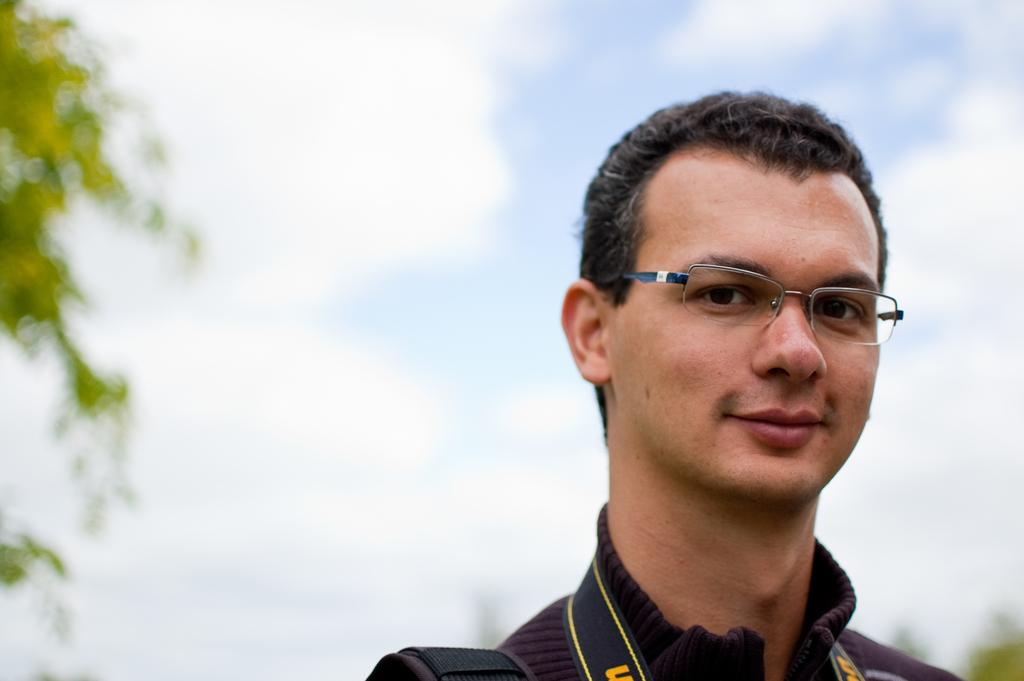What is the main subject in the foreground of the picture? There is a person in the foreground of the picture. What can be observed about the person's appearance? The person is wearing spectacles. How would you describe the background of the image? The background of the image is blurred. How many visitors are present in the mine in the image? There is no mine or visitors present in the image; it features a person in the foreground with a blurred background. 